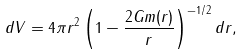<formula> <loc_0><loc_0><loc_500><loc_500>d V = 4 \pi r ^ { 2 } \left ( 1 - \frac { 2 G m ( r ) } { r } \right ) ^ { - 1 / 2 } d r ,</formula> 